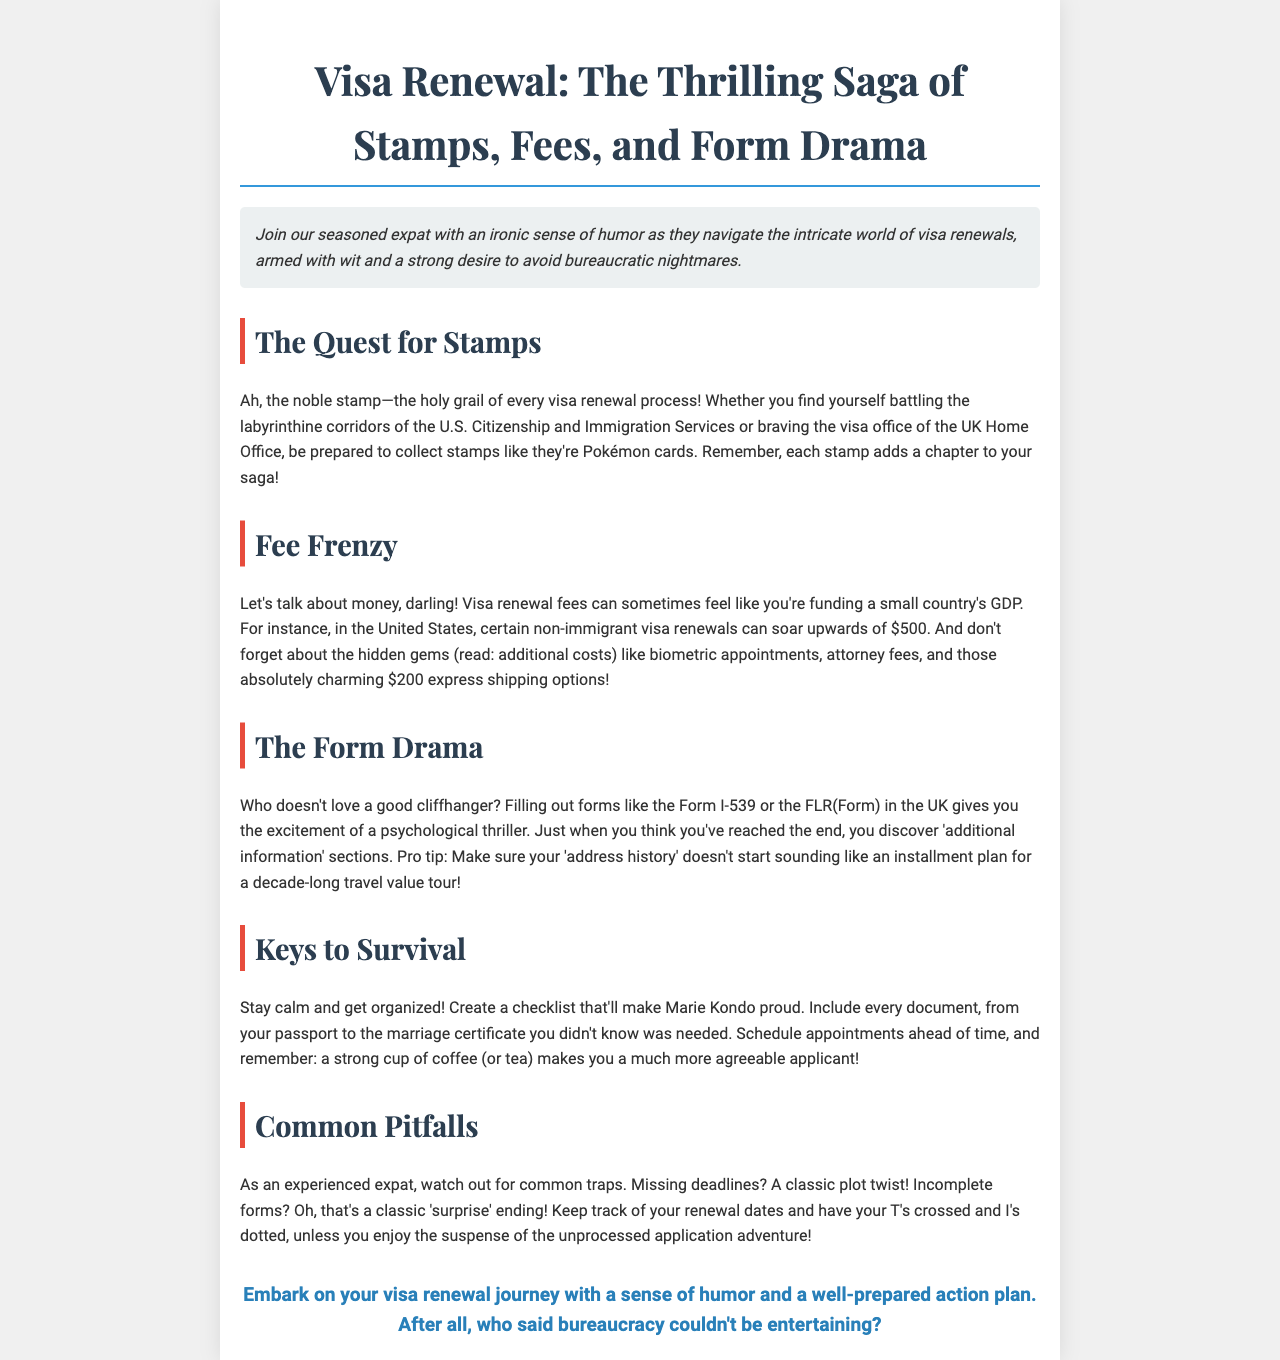What is the title of the brochure? The title of the brochure is presented prominently at the top of the document.
Answer: Visa Renewal: The Thrilling Saga of Stamps, Fees, and Form Drama How much can visa renewal fees soar in the U.S.? The document mentions a specific fee amount related to U.S. visa renewal.
Answer: upwards of $500 What document must you fill out for non-immigrant visa renewal in the U.S.? The brochure specifies the name of a form required for this process.
Answer: Form I-539 What should you create to help stay organized during the visa renewal process? The document provides a specific suggestion for maintaining organization.
Answer: a checklist What is a recommended beverage to help you during the process? A particular drink is humorously suggested to ease the experience.
Answer: coffee (or tea) What common mistake involves deadlines? The brochure refers to a classic plot twist related to timing in the renewal process.
Answer: Missing deadlines What sentiment should you maintain while embarking on your visa renewal journey? The closing section advises a particular attitude towards the process.
Answer: sense of humor 